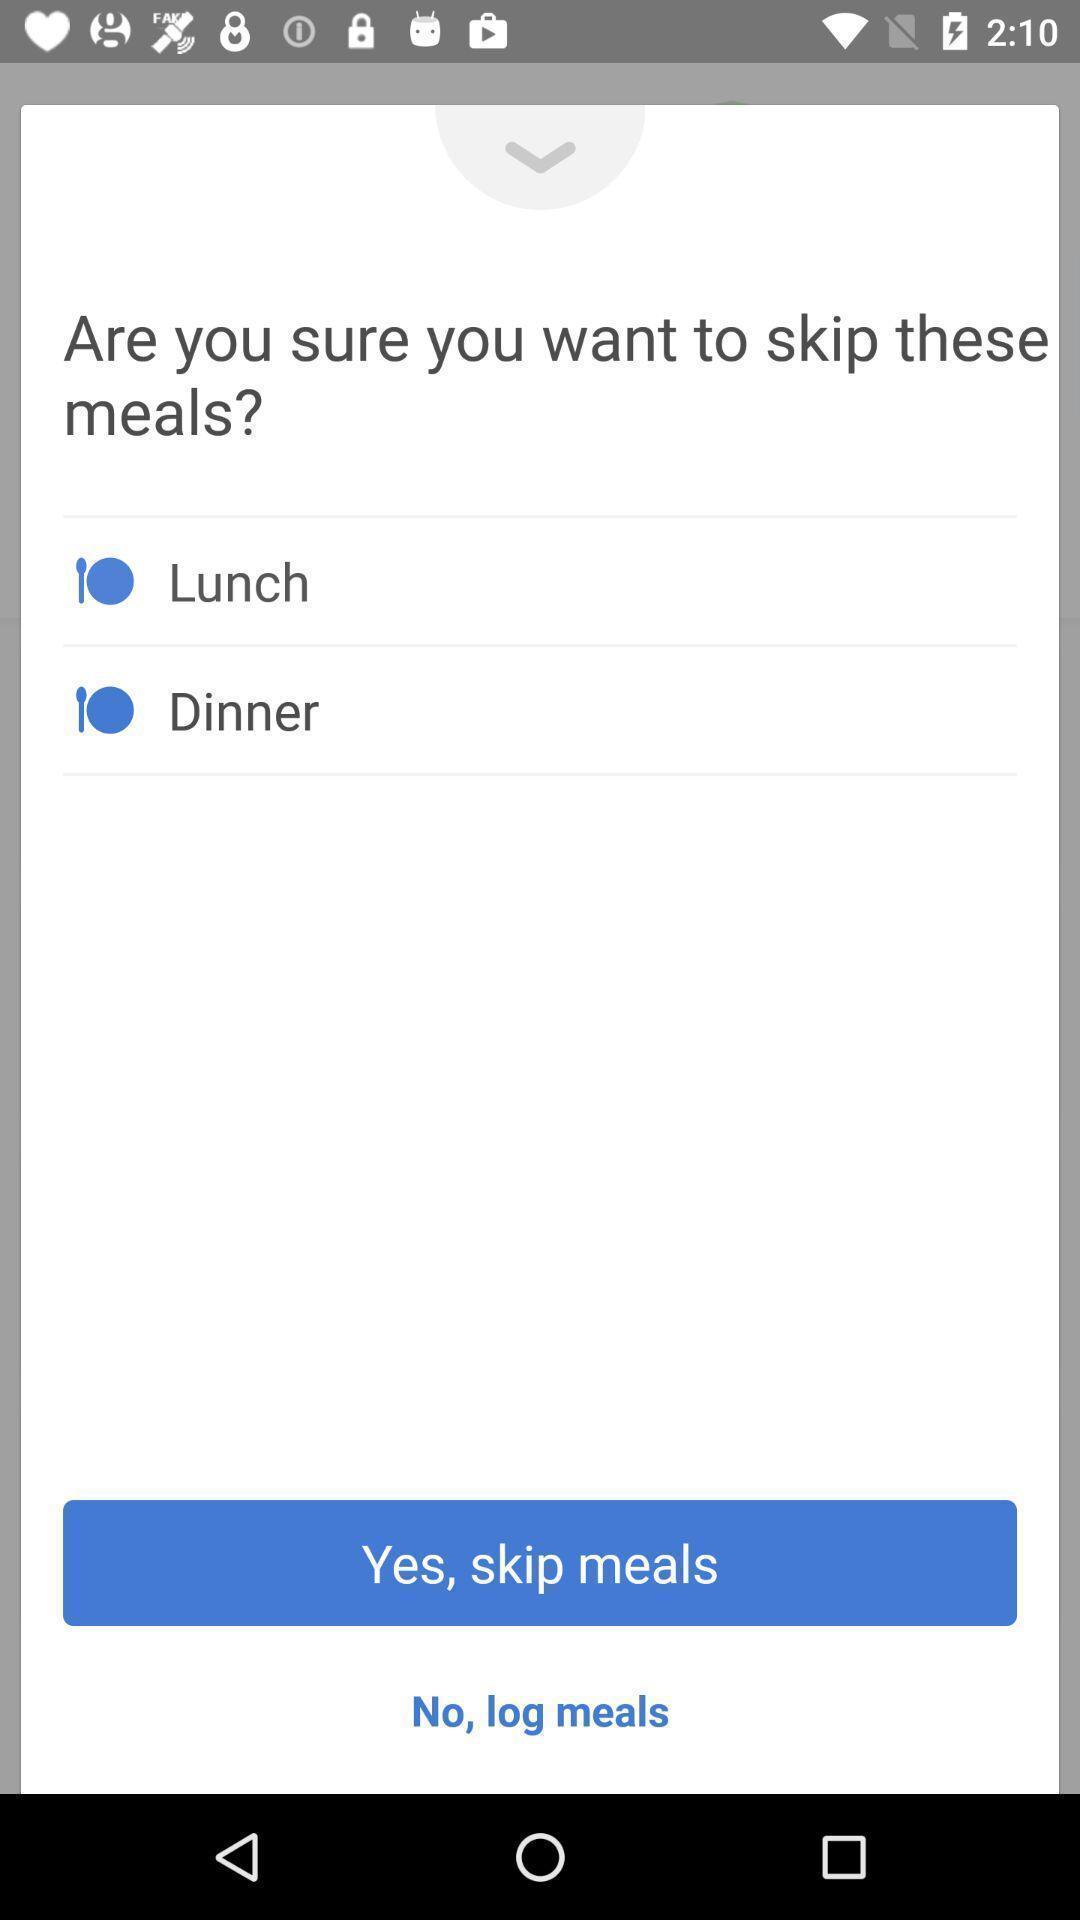Tell me about the visual elements in this screen capture. Pop up preference page displayed regarding meals. 